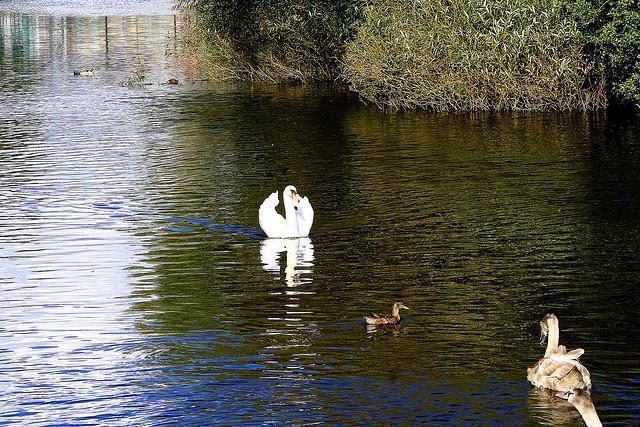What is the smaller bird in between the two larger birds?
Pick the right solution, then justify: 'Answer: answer
Rationale: rationale.'
Options: Pigeon, duck, parakeet, parrot. Answer: duck.
Rationale: Two swans are in the water.  a smaller bird with a bill is between two swans in the water. 